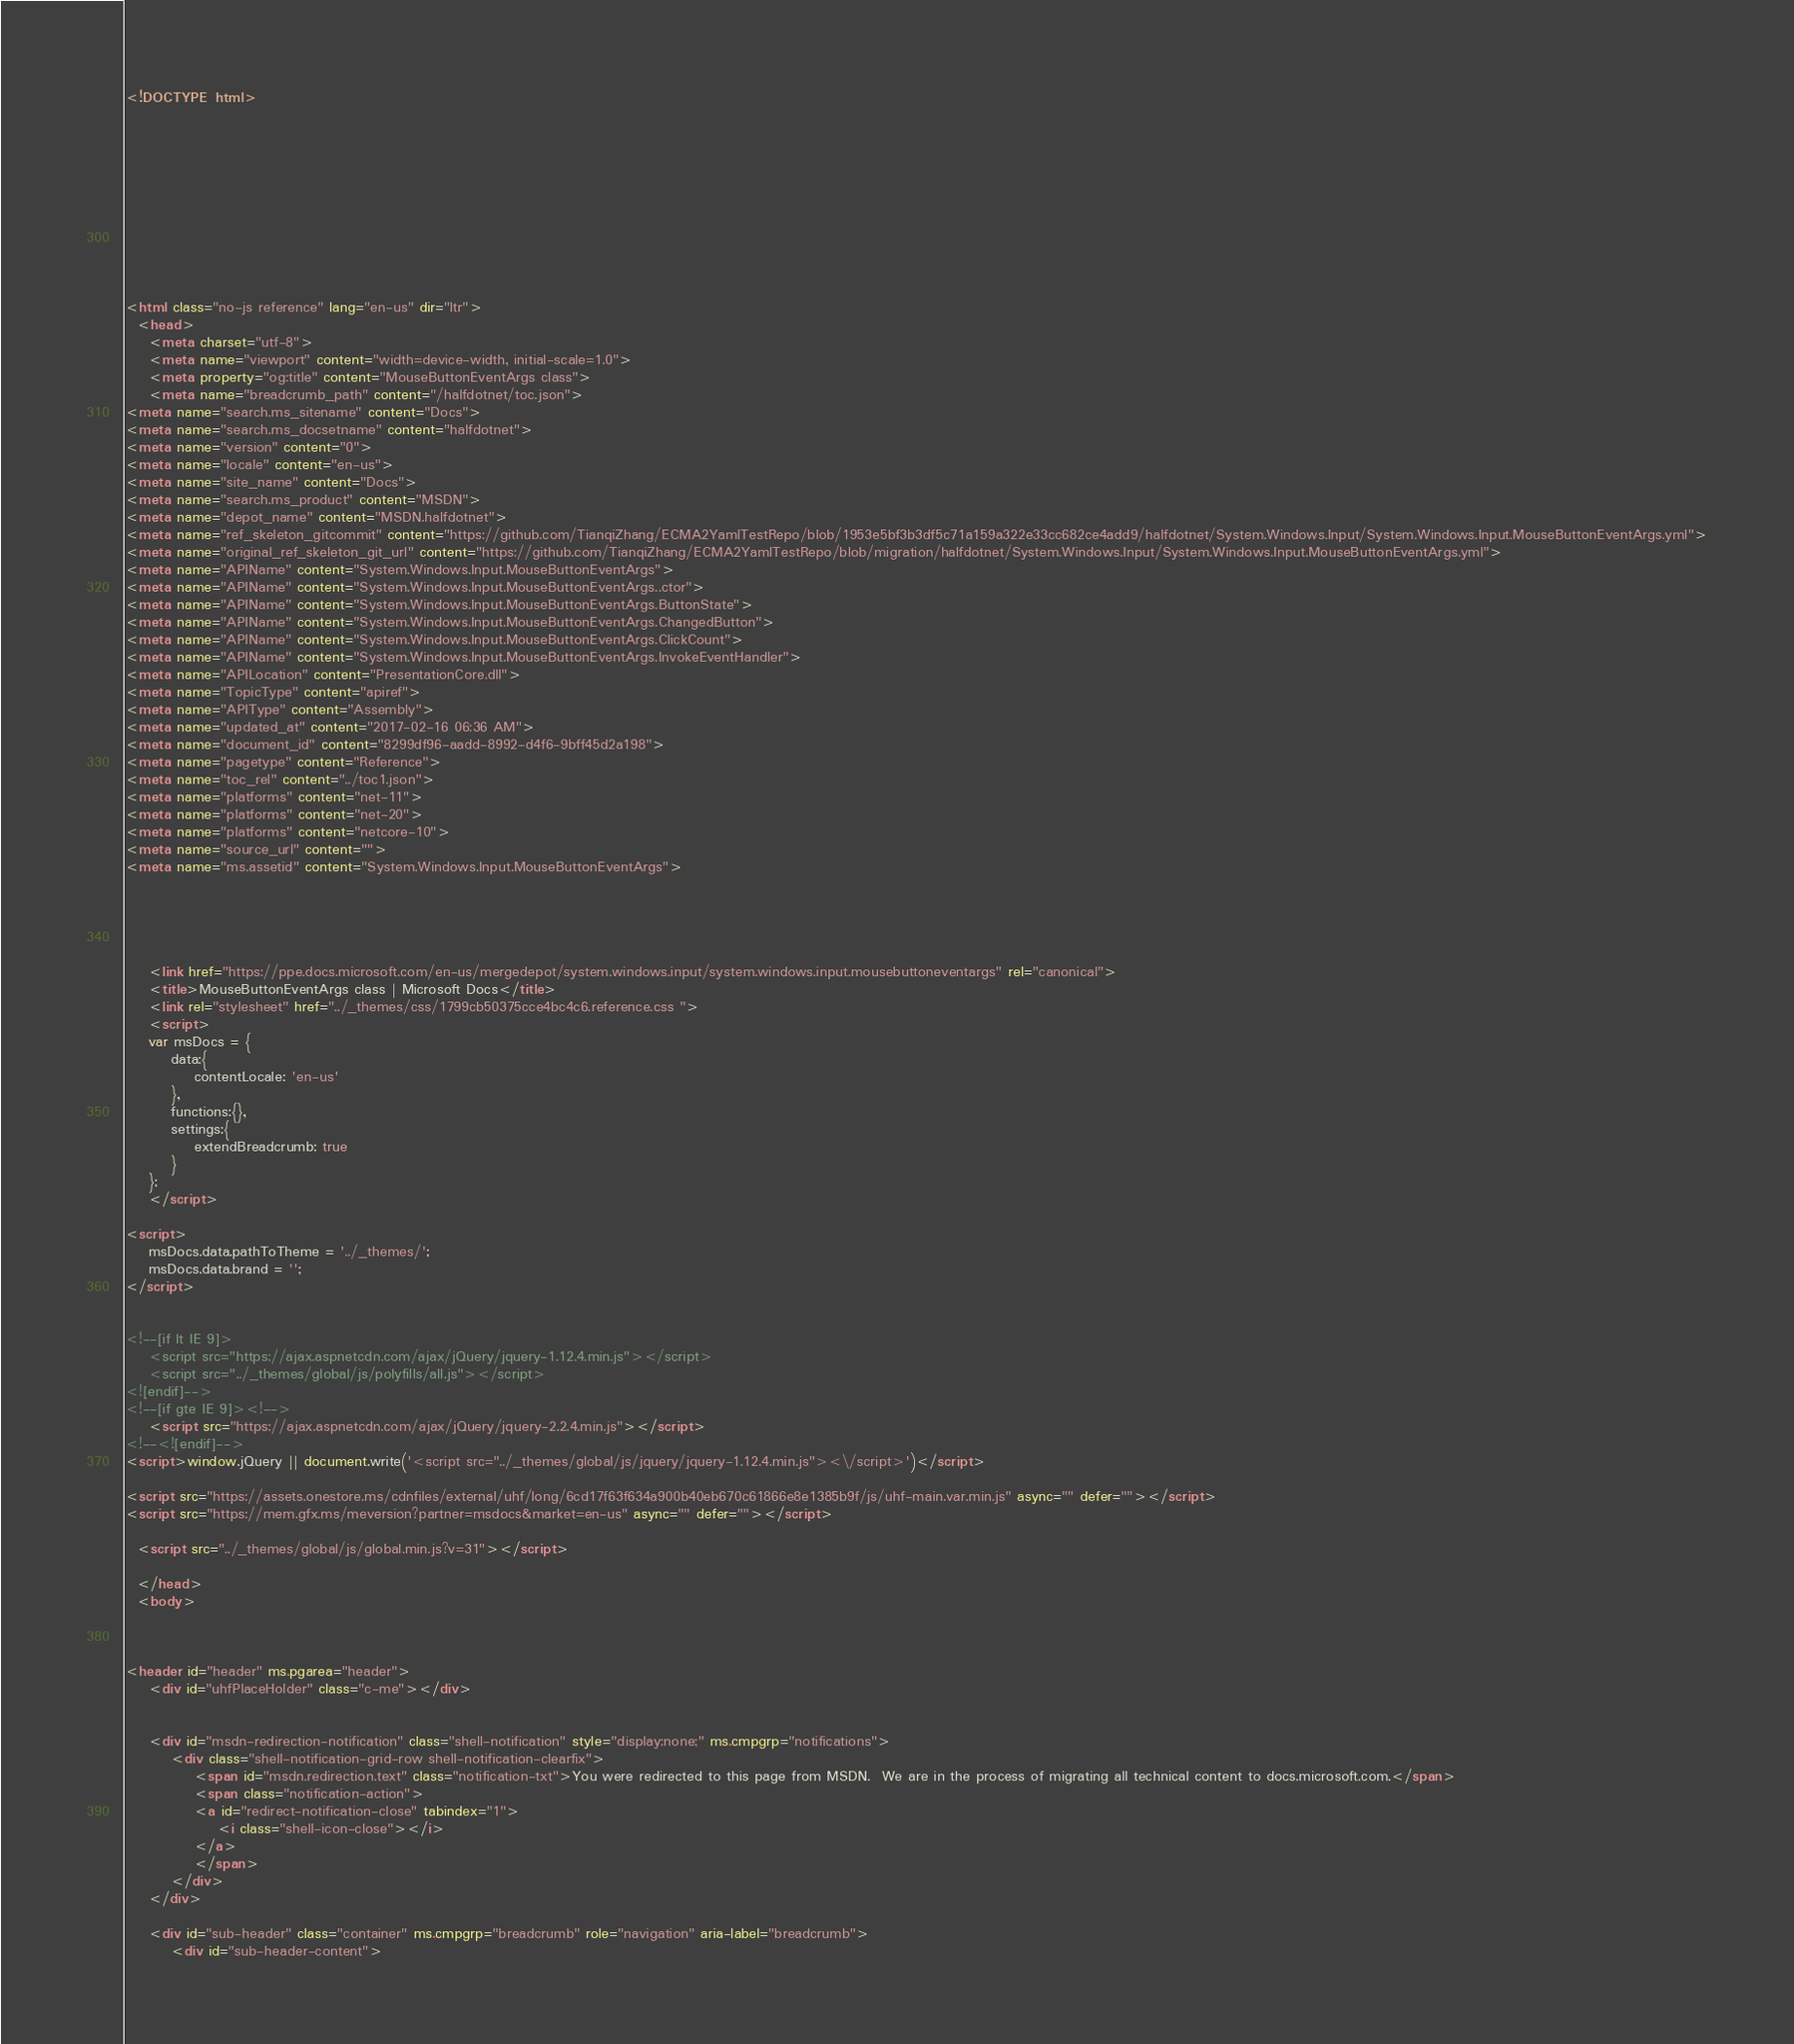<code> <loc_0><loc_0><loc_500><loc_500><_HTML_><!DOCTYPE html>



  


  


  

<html class="no-js reference" lang="en-us" dir="ltr">
  <head>
    <meta charset="utf-8">
    <meta name="viewport" content="width=device-width, initial-scale=1.0">
    <meta property="og:title" content="MouseButtonEventArgs class">
    <meta name="breadcrumb_path" content="/halfdotnet/toc.json">
<meta name="search.ms_sitename" content="Docs">
<meta name="search.ms_docsetname" content="halfdotnet">
<meta name="version" content="0">
<meta name="locale" content="en-us">
<meta name="site_name" content="Docs">
<meta name="search.ms_product" content="MSDN">
<meta name="depot_name" content="MSDN.halfdotnet">
<meta name="ref_skeleton_gitcommit" content="https://github.com/TianqiZhang/ECMA2YamlTestRepo/blob/1953e5bf3b3df5c71a159a322e33cc682ce4add9/halfdotnet/System.Windows.Input/System.Windows.Input.MouseButtonEventArgs.yml">
<meta name="original_ref_skeleton_git_url" content="https://github.com/TianqiZhang/ECMA2YamlTestRepo/blob/migration/halfdotnet/System.Windows.Input/System.Windows.Input.MouseButtonEventArgs.yml">
<meta name="APIName" content="System.Windows.Input.MouseButtonEventArgs">
<meta name="APIName" content="System.Windows.Input.MouseButtonEventArgs..ctor">
<meta name="APIName" content="System.Windows.Input.MouseButtonEventArgs.ButtonState">
<meta name="APIName" content="System.Windows.Input.MouseButtonEventArgs.ChangedButton">
<meta name="APIName" content="System.Windows.Input.MouseButtonEventArgs.ClickCount">
<meta name="APIName" content="System.Windows.Input.MouseButtonEventArgs.InvokeEventHandler">
<meta name="APILocation" content="PresentationCore.dll">
<meta name="TopicType" content="apiref">
<meta name="APIType" content="Assembly">
<meta name="updated_at" content="2017-02-16 06:36 AM">
<meta name="document_id" content="8299df96-aadd-8992-d4f6-9bff45d2a198">
<meta name="pagetype" content="Reference">
<meta name="toc_rel" content="../toc1.json">
<meta name="platforms" content="net-11">
<meta name="platforms" content="net-20">
<meta name="platforms" content="netcore-10">
<meta name="source_url" content="">
<meta name="ms.assetid" content="System.Windows.Input.MouseButtonEventArgs">

    
    
      
    
    <link href="https://ppe.docs.microsoft.com/en-us/mergedepot/system.windows.input/system.windows.input.mousebuttoneventargs" rel="canonical">
    <title>MouseButtonEventArgs class | Microsoft Docs</title>
    <link rel="stylesheet" href="../_themes/css/1799cb50375cce4bc4c6.reference.css ">
    <script>
	var msDocs = {
		data:{
			contentLocale: 'en-us'
		},
		functions:{},
		settings:{
			extendBreadcrumb: true
		}
	};
	</script>

<script>
	msDocs.data.pathToTheme = '../_themes/';
	msDocs.data.brand = '';
</script>


<!--[if lt IE 9]>
	<script src="https://ajax.aspnetcdn.com/ajax/jQuery/jquery-1.12.4.min.js"></script>
	<script src="../_themes/global/js/polyfills/all.js"></script>
<![endif]-->
<!--[if gte IE 9]><!-->
	<script src="https://ajax.aspnetcdn.com/ajax/jQuery/jquery-2.2.4.min.js"></script>
<!--<![endif]-->
<script>window.jQuery || document.write('<script src="../_themes/global/js/jquery/jquery-1.12.4.min.js"><\/script>')</script>

<script src="https://assets.onestore.ms/cdnfiles/external/uhf/long/6cd17f63f634a900b40eb670c61866e8e1385b9f/js/uhf-main.var.min.js" async="" defer=""></script>
<script src="https://mem.gfx.ms/meversion?partner=msdocs&market=en-us" async="" defer=""></script>

  <script src="../_themes/global/js/global.min.js?v=31"></script>

  </head>
  <body>



<header id="header" ms.pgarea="header">
    <div id="uhfPlaceHolder" class="c-me"></div>

    
    <div id="msdn-redirection-notification" class="shell-notification" style="display:none;" ms.cmpgrp="notifications">
        <div class="shell-notification-grid-row shell-notification-clearfix">
            <span id="msdn.redirection.text" class="notification-txt">You were redirected to this page from MSDN.  We are in the process of migrating all technical content to docs.microsoft.com.</span>
            <span class="notification-action">
            <a id="redirect-notification-close" tabindex="1">
                <i class="shell-icon-close"></i>
            </a>
            </span>
        </div>        
    </div>

    <div id="sub-header" class="container" ms.cmpgrp="breadcrumb" role="navigation" aria-label="breadcrumb">    
        <div id="sub-header-content"></code> 